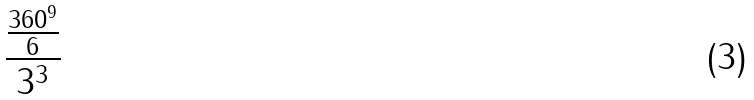Convert formula to latex. <formula><loc_0><loc_0><loc_500><loc_500>\frac { \frac { 3 6 0 ^ { 9 } } { 6 } } { 3 ^ { 3 } }</formula> 